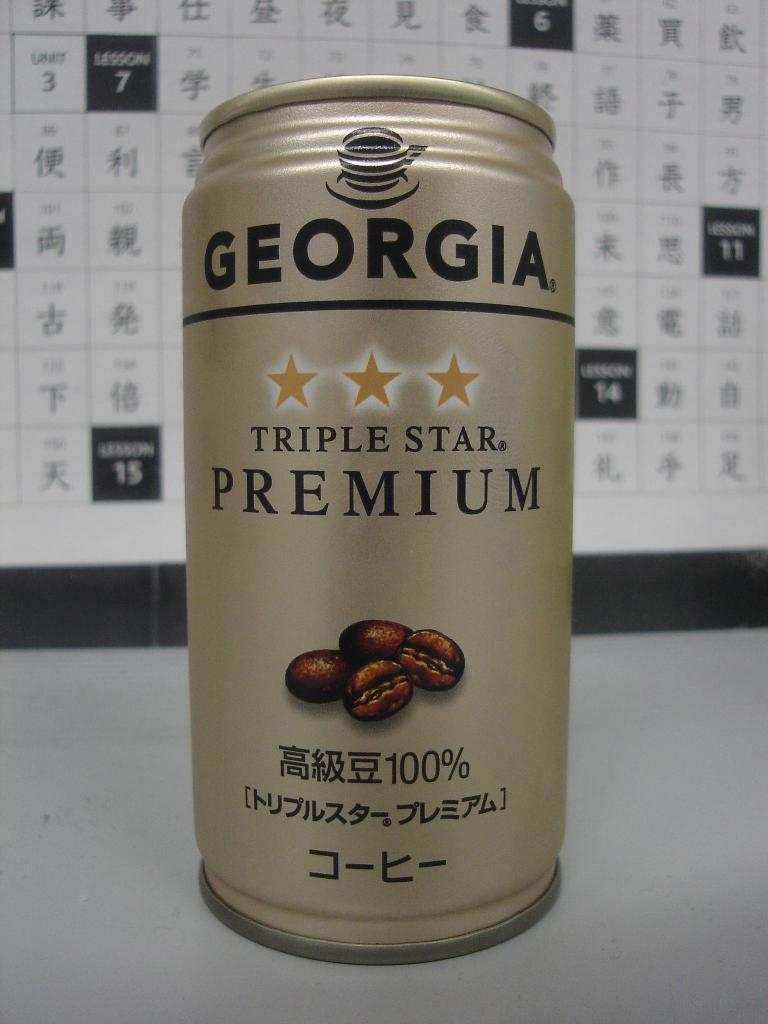<image>
Write a terse but informative summary of the picture. a can of Georgia coffee with a picture of beans on the front. 